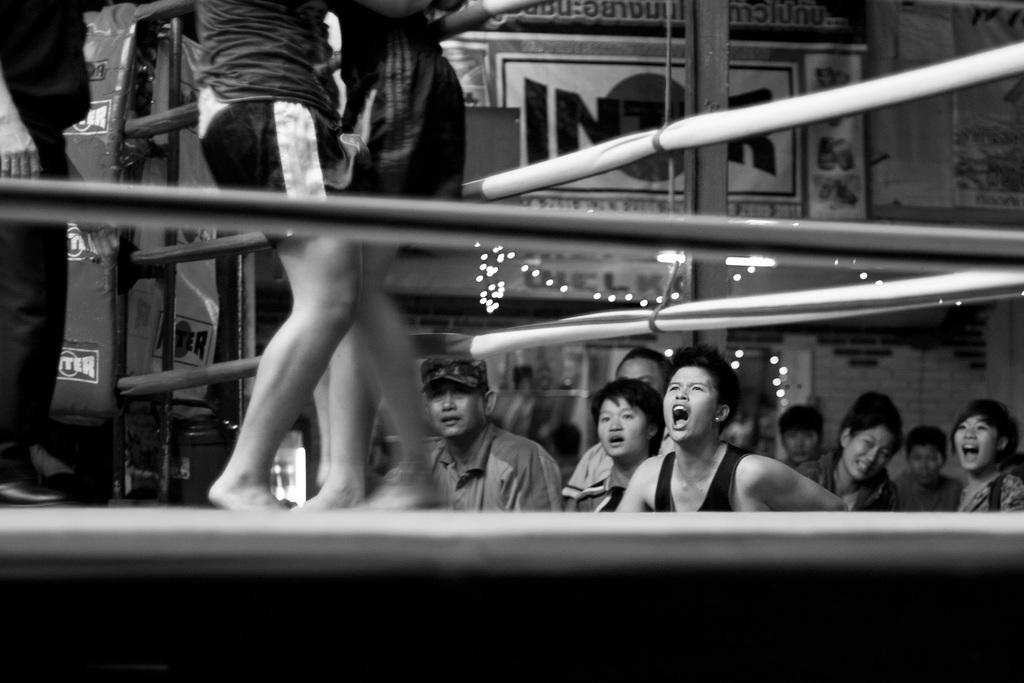What type of event is taking place in the image? The image features a wrestling stage, which suggests a wrestling event is taking place. Can you describe the people in the image? There are audience members in the image, who are likely watching the wrestling event. What is the purpose of the poster in the image? The poster in the image may be advertising the wrestling event or providing information about the performers. What can be read on the poster? There is text written on the poster, which may include details about the event or the wrestlers. What type of plant is growing on the wrestling stage in the image? There is no plant growing on the wrestling stage in the image. Can you describe the wave pattern visible in the image? There is no wave pattern visible in the image; it features a wrestling stage, audience members, and a poster. 